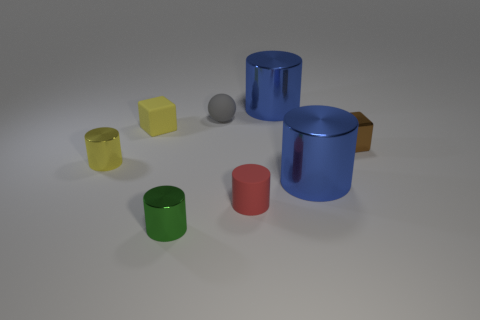Are there fewer gray matte balls than big cyan cylinders?
Ensure brevity in your answer.  No. The yellow matte object that is the same size as the red matte object is what shape?
Your response must be concise. Cube. How many other objects are the same color as the small sphere?
Your answer should be very brief. 0. How many blue shiny cylinders are there?
Ensure brevity in your answer.  2. What number of tiny blocks are both in front of the tiny yellow cube and on the left side of the metallic cube?
Your answer should be very brief. 0. What material is the tiny green cylinder?
Give a very brief answer. Metal. Is there a large gray metal sphere?
Make the answer very short. No. What color is the tiny cylinder that is right of the gray thing?
Keep it short and to the point. Red. There is a large blue metallic cylinder that is right of the big blue cylinder that is behind the tiny yellow metallic thing; what number of tiny shiny cubes are to the left of it?
Your response must be concise. 0. What material is the tiny cylinder that is both on the right side of the yellow matte block and to the left of the red thing?
Offer a very short reply. Metal. 